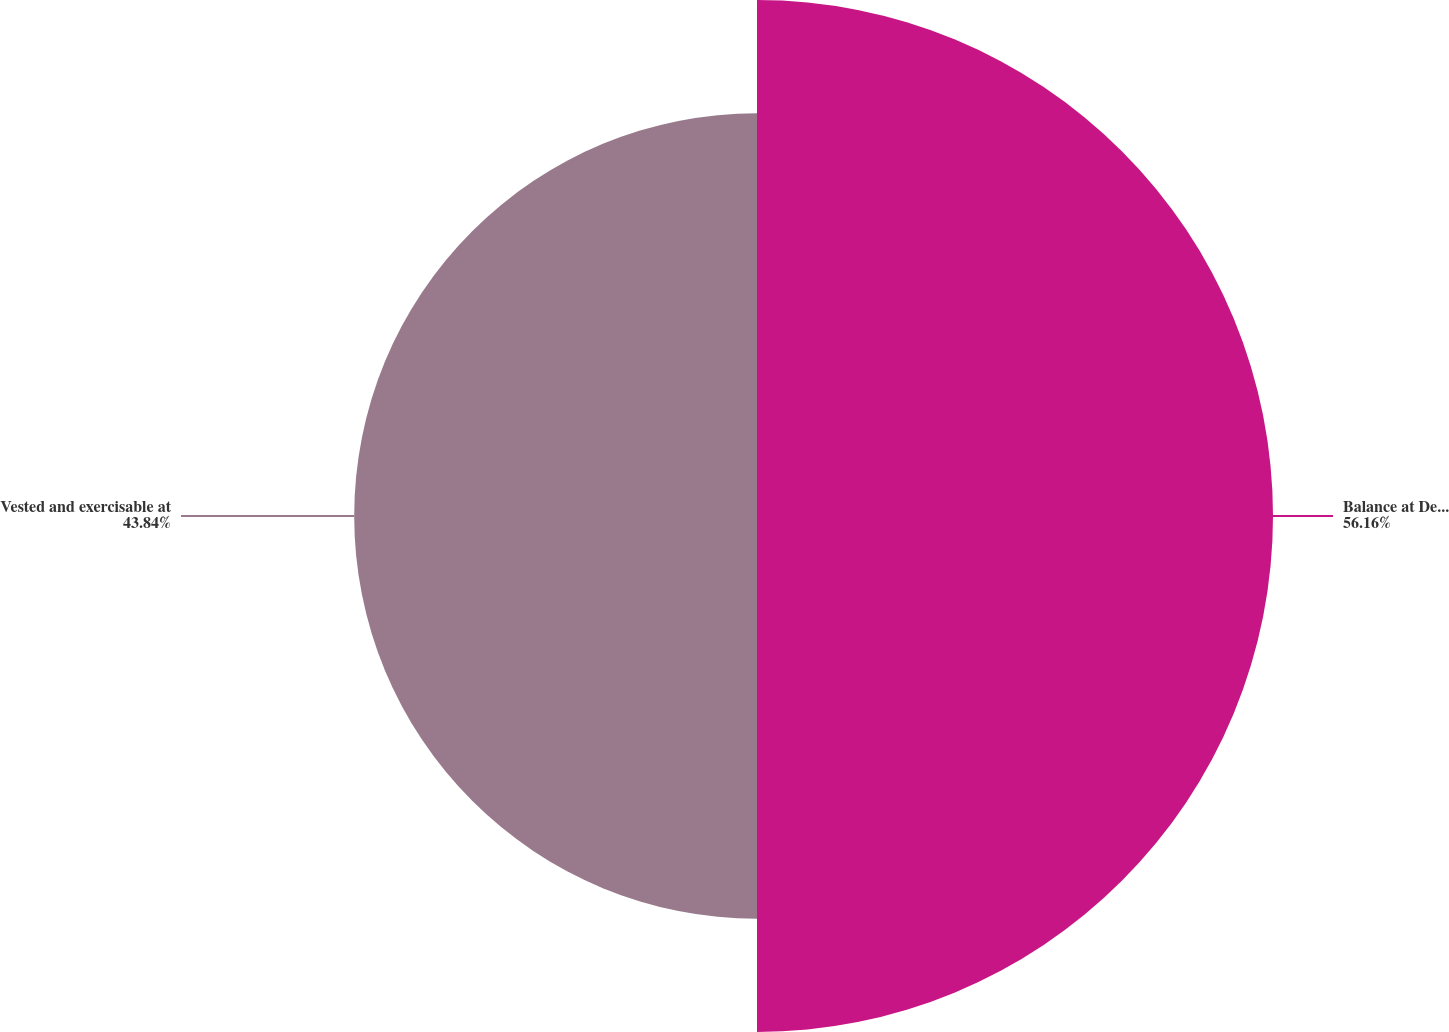<chart> <loc_0><loc_0><loc_500><loc_500><pie_chart><fcel>Balance at December 31<fcel>Vested and exercisable at<nl><fcel>56.16%<fcel>43.84%<nl></chart> 